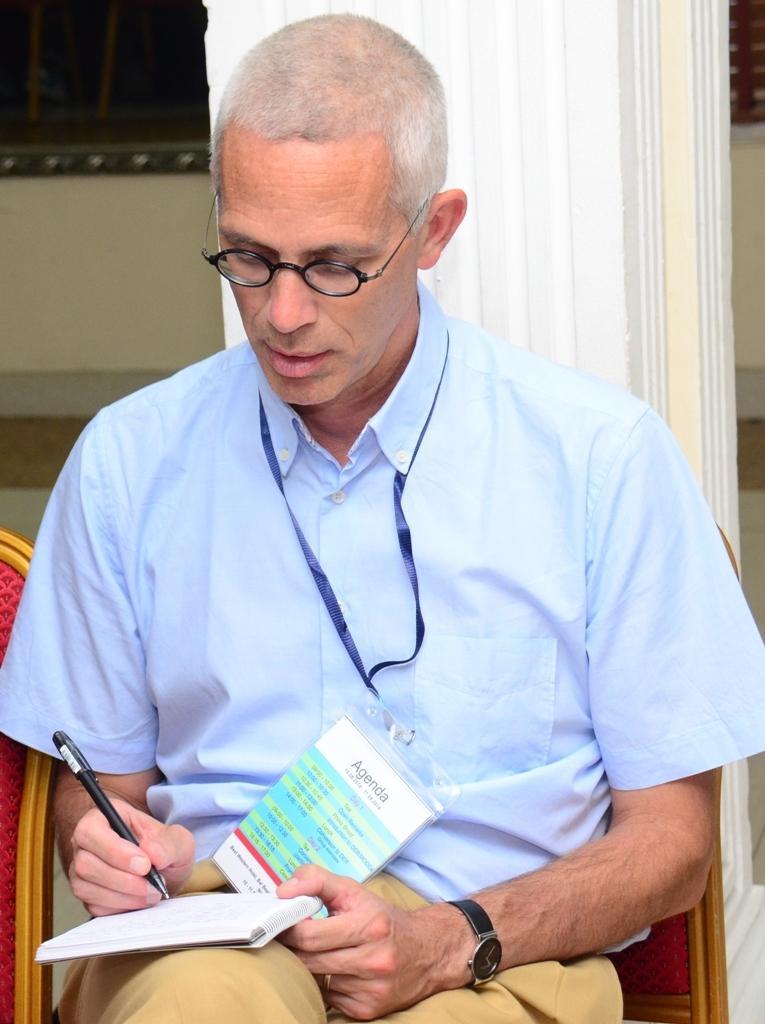Could you give a brief overview of what you see in this image? In the middle of the image, there is a person in a shirt, sitting and writing something on the white color page of a book. In the background, there is a white color pillar and there is a wall. 